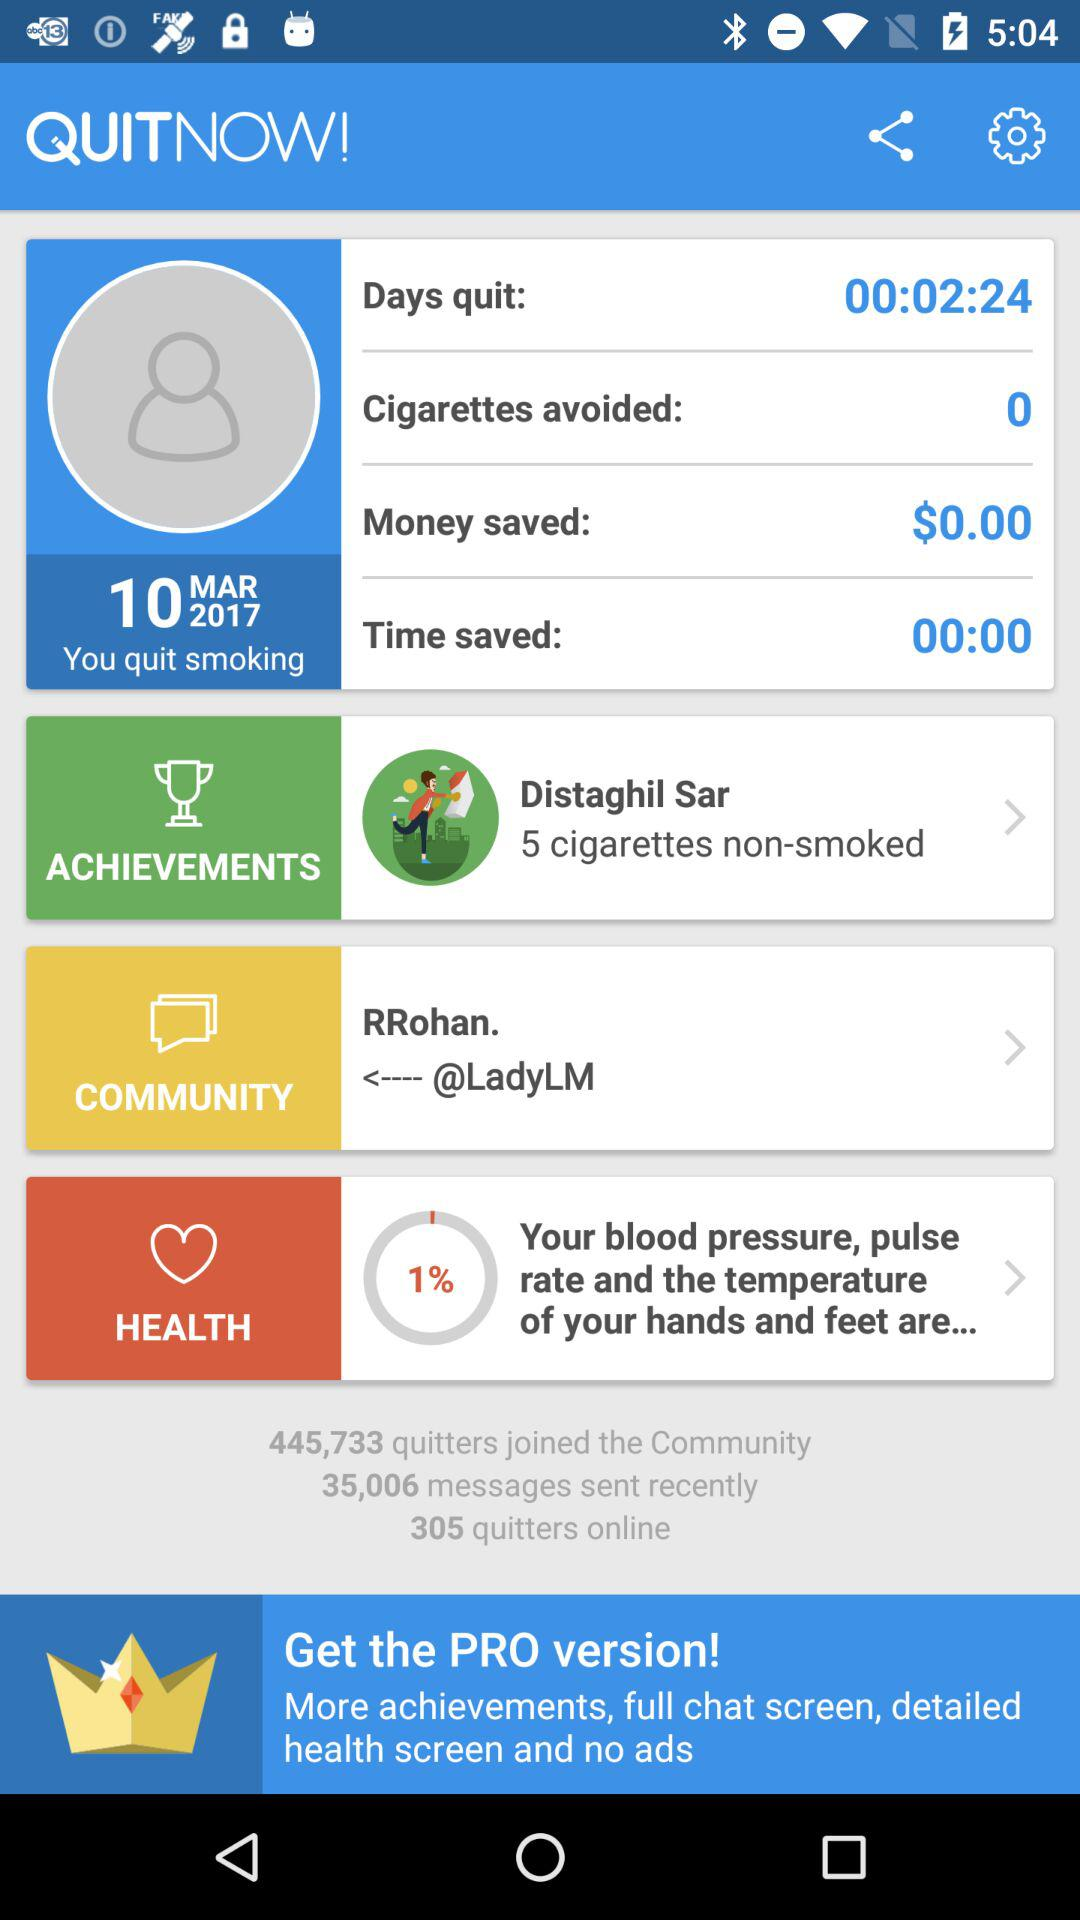How much time has been saved since quitting smoking?
Answer the question using a single word or phrase. 00:02:24 